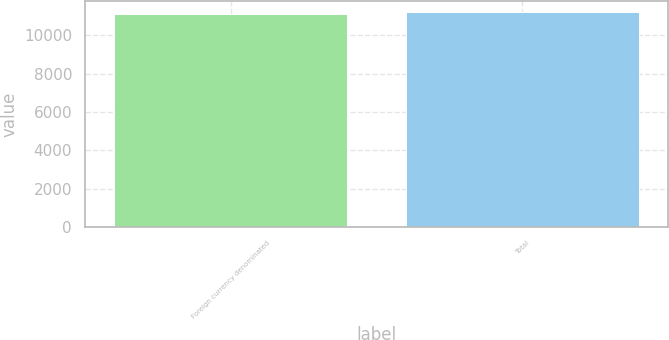Convert chart to OTSL. <chart><loc_0><loc_0><loc_500><loc_500><bar_chart><fcel>Foreign currency denominated<fcel>Total<nl><fcel>11113<fcel>11213<nl></chart> 